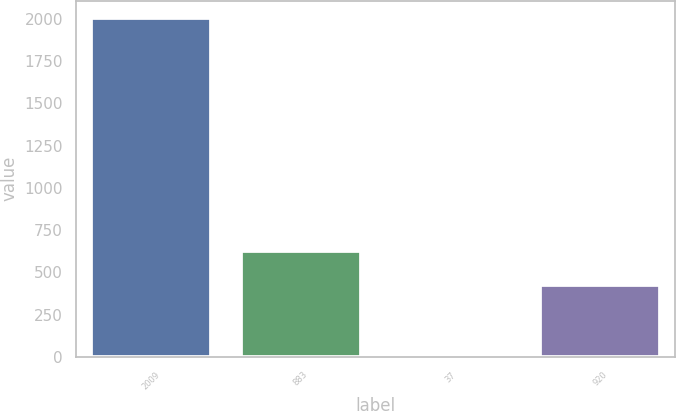Convert chart to OTSL. <chart><loc_0><loc_0><loc_500><loc_500><bar_chart><fcel>2009<fcel>883<fcel>37<fcel>920<nl><fcel>2008<fcel>623.9<fcel>19<fcel>425<nl></chart> 